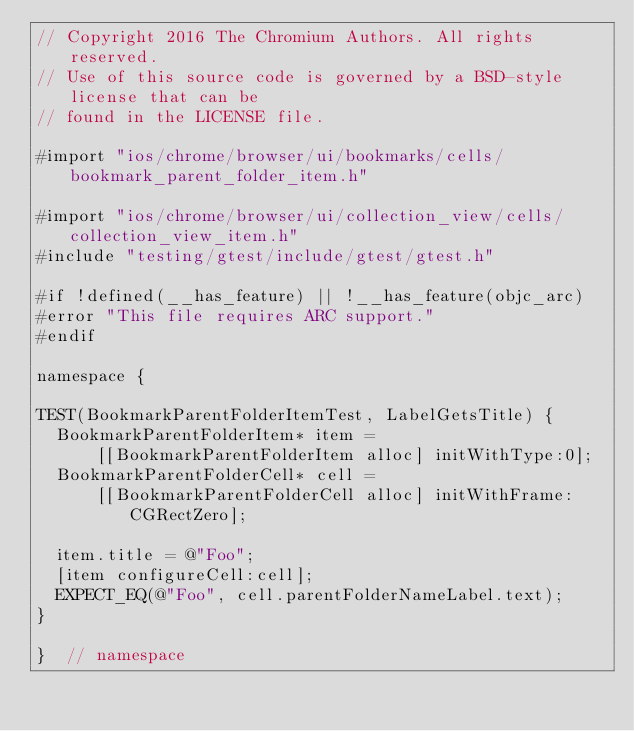Convert code to text. <code><loc_0><loc_0><loc_500><loc_500><_ObjectiveC_>// Copyright 2016 The Chromium Authors. All rights reserved.
// Use of this source code is governed by a BSD-style license that can be
// found in the LICENSE file.

#import "ios/chrome/browser/ui/bookmarks/cells/bookmark_parent_folder_item.h"

#import "ios/chrome/browser/ui/collection_view/cells/collection_view_item.h"
#include "testing/gtest/include/gtest/gtest.h"

#if !defined(__has_feature) || !__has_feature(objc_arc)
#error "This file requires ARC support."
#endif

namespace {

TEST(BookmarkParentFolderItemTest, LabelGetsTitle) {
  BookmarkParentFolderItem* item =
      [[BookmarkParentFolderItem alloc] initWithType:0];
  BookmarkParentFolderCell* cell =
      [[BookmarkParentFolderCell alloc] initWithFrame:CGRectZero];

  item.title = @"Foo";
  [item configureCell:cell];
  EXPECT_EQ(@"Foo", cell.parentFolderNameLabel.text);
}

}  // namespace
</code> 